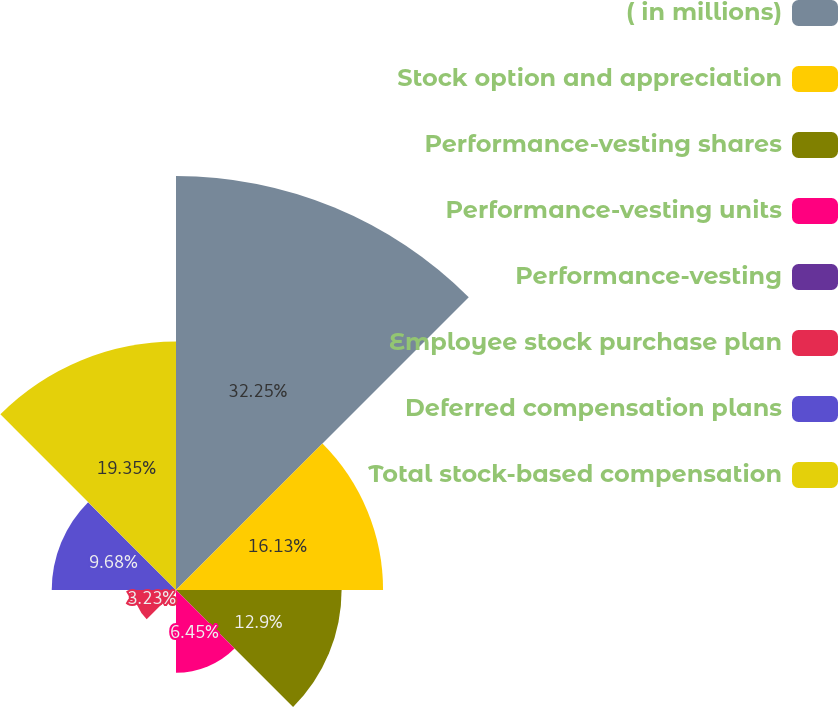Convert chart to OTSL. <chart><loc_0><loc_0><loc_500><loc_500><pie_chart><fcel>( in millions)<fcel>Stock option and appreciation<fcel>Performance-vesting shares<fcel>Performance-vesting units<fcel>Performance-vesting<fcel>Employee stock purchase plan<fcel>Deferred compensation plans<fcel>Total stock-based compensation<nl><fcel>32.25%<fcel>16.13%<fcel>12.9%<fcel>6.45%<fcel>0.01%<fcel>3.23%<fcel>9.68%<fcel>19.35%<nl></chart> 